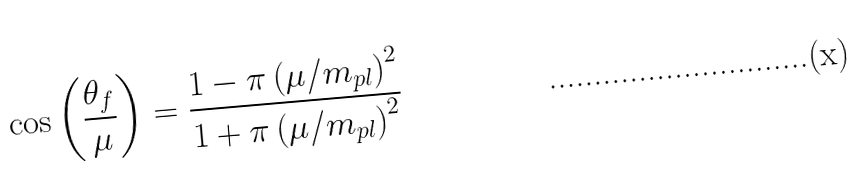Convert formula to latex. <formula><loc_0><loc_0><loc_500><loc_500>\cos \left ( { \frac { \theta _ { f } } { \mu } } \right ) = { \frac { 1 - \pi \left ( \mu / m _ { p l } \right ) ^ { 2 } } { 1 + \pi \left ( \mu / m _ { p l } \right ) ^ { 2 } } }</formula> 